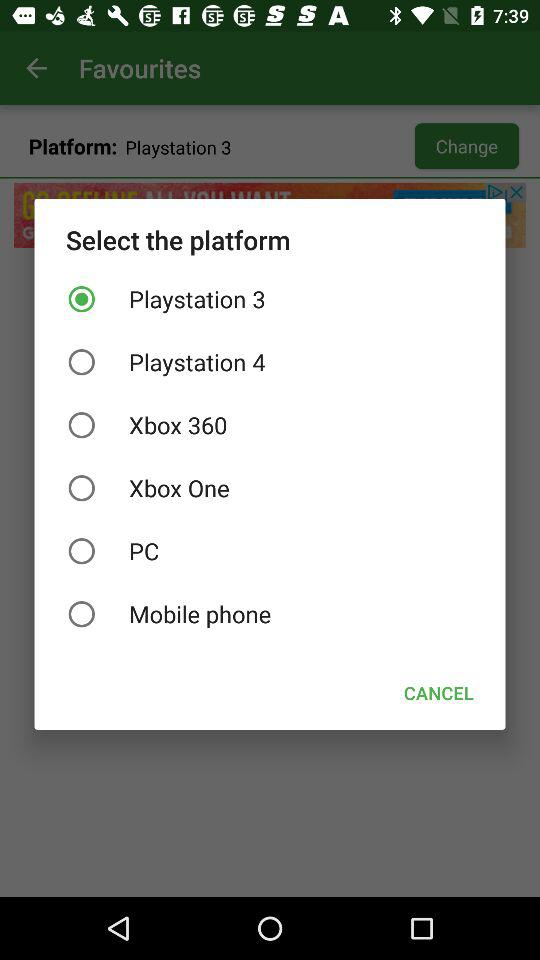How many platforms are there in total?
Answer the question using a single word or phrase. 6 